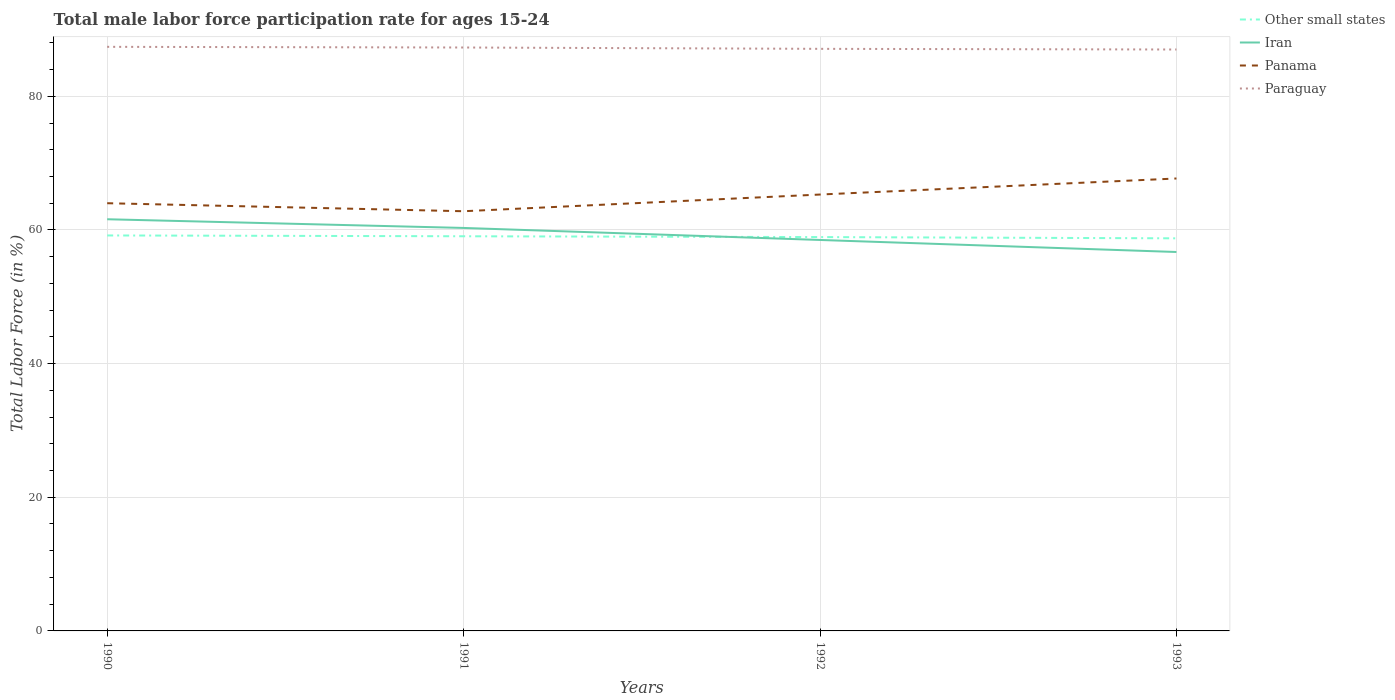Across all years, what is the maximum male labor force participation rate in Other small states?
Your answer should be very brief. 58.75. What is the total male labor force participation rate in Panama in the graph?
Your answer should be compact. -1.3. What is the difference between the highest and the second highest male labor force participation rate in Iran?
Provide a succinct answer. 4.9. What is the difference between the highest and the lowest male labor force participation rate in Other small states?
Provide a short and direct response. 2. Is the male labor force participation rate in Paraguay strictly greater than the male labor force participation rate in Other small states over the years?
Provide a succinct answer. No. Does the graph contain any zero values?
Offer a terse response. No. Does the graph contain grids?
Make the answer very short. Yes. Where does the legend appear in the graph?
Offer a very short reply. Top right. What is the title of the graph?
Ensure brevity in your answer.  Total male labor force participation rate for ages 15-24. Does "American Samoa" appear as one of the legend labels in the graph?
Your answer should be very brief. No. What is the label or title of the X-axis?
Your response must be concise. Years. What is the label or title of the Y-axis?
Give a very brief answer. Total Labor Force (in %). What is the Total Labor Force (in %) in Other small states in 1990?
Offer a very short reply. 59.18. What is the Total Labor Force (in %) in Iran in 1990?
Make the answer very short. 61.6. What is the Total Labor Force (in %) of Panama in 1990?
Your response must be concise. 64. What is the Total Labor Force (in %) of Paraguay in 1990?
Make the answer very short. 87.4. What is the Total Labor Force (in %) of Other small states in 1991?
Provide a succinct answer. 59.05. What is the Total Labor Force (in %) of Iran in 1991?
Your answer should be compact. 60.3. What is the Total Labor Force (in %) in Panama in 1991?
Your response must be concise. 62.8. What is the Total Labor Force (in %) in Paraguay in 1991?
Offer a terse response. 87.3. What is the Total Labor Force (in %) in Other small states in 1992?
Provide a succinct answer. 58.93. What is the Total Labor Force (in %) in Iran in 1992?
Your answer should be very brief. 58.5. What is the Total Labor Force (in %) in Panama in 1992?
Your response must be concise. 65.3. What is the Total Labor Force (in %) of Paraguay in 1992?
Offer a very short reply. 87.1. What is the Total Labor Force (in %) of Other small states in 1993?
Provide a short and direct response. 58.75. What is the Total Labor Force (in %) in Iran in 1993?
Your answer should be very brief. 56.7. What is the Total Labor Force (in %) of Panama in 1993?
Your answer should be compact. 67.7. Across all years, what is the maximum Total Labor Force (in %) of Other small states?
Keep it short and to the point. 59.18. Across all years, what is the maximum Total Labor Force (in %) of Iran?
Keep it short and to the point. 61.6. Across all years, what is the maximum Total Labor Force (in %) in Panama?
Provide a short and direct response. 67.7. Across all years, what is the maximum Total Labor Force (in %) of Paraguay?
Offer a terse response. 87.4. Across all years, what is the minimum Total Labor Force (in %) of Other small states?
Your answer should be very brief. 58.75. Across all years, what is the minimum Total Labor Force (in %) in Iran?
Ensure brevity in your answer.  56.7. Across all years, what is the minimum Total Labor Force (in %) in Panama?
Your answer should be very brief. 62.8. What is the total Total Labor Force (in %) in Other small states in the graph?
Offer a terse response. 235.91. What is the total Total Labor Force (in %) in Iran in the graph?
Offer a terse response. 237.1. What is the total Total Labor Force (in %) of Panama in the graph?
Provide a succinct answer. 259.8. What is the total Total Labor Force (in %) of Paraguay in the graph?
Offer a very short reply. 348.8. What is the difference between the Total Labor Force (in %) in Other small states in 1990 and that in 1991?
Your answer should be compact. 0.12. What is the difference between the Total Labor Force (in %) of Iran in 1990 and that in 1991?
Your answer should be very brief. 1.3. What is the difference between the Total Labor Force (in %) of Paraguay in 1990 and that in 1991?
Offer a terse response. 0.1. What is the difference between the Total Labor Force (in %) in Other small states in 1990 and that in 1992?
Provide a short and direct response. 0.24. What is the difference between the Total Labor Force (in %) in Paraguay in 1990 and that in 1992?
Your answer should be very brief. 0.3. What is the difference between the Total Labor Force (in %) of Other small states in 1990 and that in 1993?
Make the answer very short. 0.43. What is the difference between the Total Labor Force (in %) of Other small states in 1991 and that in 1992?
Provide a short and direct response. 0.12. What is the difference between the Total Labor Force (in %) in Other small states in 1991 and that in 1993?
Your answer should be compact. 0.31. What is the difference between the Total Labor Force (in %) in Iran in 1991 and that in 1993?
Your answer should be very brief. 3.6. What is the difference between the Total Labor Force (in %) of Paraguay in 1991 and that in 1993?
Offer a very short reply. 0.3. What is the difference between the Total Labor Force (in %) of Other small states in 1992 and that in 1993?
Make the answer very short. 0.19. What is the difference between the Total Labor Force (in %) of Panama in 1992 and that in 1993?
Your answer should be very brief. -2.4. What is the difference between the Total Labor Force (in %) in Other small states in 1990 and the Total Labor Force (in %) in Iran in 1991?
Offer a terse response. -1.12. What is the difference between the Total Labor Force (in %) in Other small states in 1990 and the Total Labor Force (in %) in Panama in 1991?
Give a very brief answer. -3.62. What is the difference between the Total Labor Force (in %) of Other small states in 1990 and the Total Labor Force (in %) of Paraguay in 1991?
Your answer should be compact. -28.12. What is the difference between the Total Labor Force (in %) in Iran in 1990 and the Total Labor Force (in %) in Paraguay in 1991?
Your response must be concise. -25.7. What is the difference between the Total Labor Force (in %) of Panama in 1990 and the Total Labor Force (in %) of Paraguay in 1991?
Provide a succinct answer. -23.3. What is the difference between the Total Labor Force (in %) of Other small states in 1990 and the Total Labor Force (in %) of Iran in 1992?
Provide a short and direct response. 0.68. What is the difference between the Total Labor Force (in %) in Other small states in 1990 and the Total Labor Force (in %) in Panama in 1992?
Ensure brevity in your answer.  -6.12. What is the difference between the Total Labor Force (in %) in Other small states in 1990 and the Total Labor Force (in %) in Paraguay in 1992?
Ensure brevity in your answer.  -27.92. What is the difference between the Total Labor Force (in %) in Iran in 1990 and the Total Labor Force (in %) in Paraguay in 1992?
Provide a short and direct response. -25.5. What is the difference between the Total Labor Force (in %) of Panama in 1990 and the Total Labor Force (in %) of Paraguay in 1992?
Provide a succinct answer. -23.1. What is the difference between the Total Labor Force (in %) in Other small states in 1990 and the Total Labor Force (in %) in Iran in 1993?
Keep it short and to the point. 2.48. What is the difference between the Total Labor Force (in %) of Other small states in 1990 and the Total Labor Force (in %) of Panama in 1993?
Your response must be concise. -8.52. What is the difference between the Total Labor Force (in %) in Other small states in 1990 and the Total Labor Force (in %) in Paraguay in 1993?
Offer a very short reply. -27.82. What is the difference between the Total Labor Force (in %) of Iran in 1990 and the Total Labor Force (in %) of Panama in 1993?
Make the answer very short. -6.1. What is the difference between the Total Labor Force (in %) in Iran in 1990 and the Total Labor Force (in %) in Paraguay in 1993?
Provide a short and direct response. -25.4. What is the difference between the Total Labor Force (in %) of Panama in 1990 and the Total Labor Force (in %) of Paraguay in 1993?
Offer a very short reply. -23. What is the difference between the Total Labor Force (in %) of Other small states in 1991 and the Total Labor Force (in %) of Iran in 1992?
Your answer should be very brief. 0.55. What is the difference between the Total Labor Force (in %) of Other small states in 1991 and the Total Labor Force (in %) of Panama in 1992?
Provide a short and direct response. -6.25. What is the difference between the Total Labor Force (in %) of Other small states in 1991 and the Total Labor Force (in %) of Paraguay in 1992?
Keep it short and to the point. -28.05. What is the difference between the Total Labor Force (in %) in Iran in 1991 and the Total Labor Force (in %) in Paraguay in 1992?
Ensure brevity in your answer.  -26.8. What is the difference between the Total Labor Force (in %) in Panama in 1991 and the Total Labor Force (in %) in Paraguay in 1992?
Ensure brevity in your answer.  -24.3. What is the difference between the Total Labor Force (in %) in Other small states in 1991 and the Total Labor Force (in %) in Iran in 1993?
Offer a very short reply. 2.35. What is the difference between the Total Labor Force (in %) of Other small states in 1991 and the Total Labor Force (in %) of Panama in 1993?
Your response must be concise. -8.65. What is the difference between the Total Labor Force (in %) of Other small states in 1991 and the Total Labor Force (in %) of Paraguay in 1993?
Your answer should be very brief. -27.95. What is the difference between the Total Labor Force (in %) of Iran in 1991 and the Total Labor Force (in %) of Paraguay in 1993?
Provide a succinct answer. -26.7. What is the difference between the Total Labor Force (in %) of Panama in 1991 and the Total Labor Force (in %) of Paraguay in 1993?
Provide a succinct answer. -24.2. What is the difference between the Total Labor Force (in %) in Other small states in 1992 and the Total Labor Force (in %) in Iran in 1993?
Provide a succinct answer. 2.23. What is the difference between the Total Labor Force (in %) in Other small states in 1992 and the Total Labor Force (in %) in Panama in 1993?
Your answer should be compact. -8.77. What is the difference between the Total Labor Force (in %) in Other small states in 1992 and the Total Labor Force (in %) in Paraguay in 1993?
Your answer should be compact. -28.07. What is the difference between the Total Labor Force (in %) in Iran in 1992 and the Total Labor Force (in %) in Paraguay in 1993?
Your response must be concise. -28.5. What is the difference between the Total Labor Force (in %) of Panama in 1992 and the Total Labor Force (in %) of Paraguay in 1993?
Give a very brief answer. -21.7. What is the average Total Labor Force (in %) of Other small states per year?
Your answer should be compact. 58.98. What is the average Total Labor Force (in %) of Iran per year?
Give a very brief answer. 59.27. What is the average Total Labor Force (in %) of Panama per year?
Provide a succinct answer. 64.95. What is the average Total Labor Force (in %) of Paraguay per year?
Provide a short and direct response. 87.2. In the year 1990, what is the difference between the Total Labor Force (in %) in Other small states and Total Labor Force (in %) in Iran?
Your answer should be compact. -2.42. In the year 1990, what is the difference between the Total Labor Force (in %) in Other small states and Total Labor Force (in %) in Panama?
Offer a terse response. -4.82. In the year 1990, what is the difference between the Total Labor Force (in %) of Other small states and Total Labor Force (in %) of Paraguay?
Offer a terse response. -28.22. In the year 1990, what is the difference between the Total Labor Force (in %) in Iran and Total Labor Force (in %) in Paraguay?
Offer a terse response. -25.8. In the year 1990, what is the difference between the Total Labor Force (in %) of Panama and Total Labor Force (in %) of Paraguay?
Provide a succinct answer. -23.4. In the year 1991, what is the difference between the Total Labor Force (in %) in Other small states and Total Labor Force (in %) in Iran?
Offer a terse response. -1.25. In the year 1991, what is the difference between the Total Labor Force (in %) of Other small states and Total Labor Force (in %) of Panama?
Your answer should be compact. -3.75. In the year 1991, what is the difference between the Total Labor Force (in %) of Other small states and Total Labor Force (in %) of Paraguay?
Offer a very short reply. -28.25. In the year 1991, what is the difference between the Total Labor Force (in %) of Panama and Total Labor Force (in %) of Paraguay?
Your answer should be compact. -24.5. In the year 1992, what is the difference between the Total Labor Force (in %) in Other small states and Total Labor Force (in %) in Iran?
Keep it short and to the point. 0.43. In the year 1992, what is the difference between the Total Labor Force (in %) of Other small states and Total Labor Force (in %) of Panama?
Offer a very short reply. -6.37. In the year 1992, what is the difference between the Total Labor Force (in %) of Other small states and Total Labor Force (in %) of Paraguay?
Offer a terse response. -28.17. In the year 1992, what is the difference between the Total Labor Force (in %) of Iran and Total Labor Force (in %) of Paraguay?
Your response must be concise. -28.6. In the year 1992, what is the difference between the Total Labor Force (in %) of Panama and Total Labor Force (in %) of Paraguay?
Make the answer very short. -21.8. In the year 1993, what is the difference between the Total Labor Force (in %) of Other small states and Total Labor Force (in %) of Iran?
Provide a short and direct response. 2.05. In the year 1993, what is the difference between the Total Labor Force (in %) of Other small states and Total Labor Force (in %) of Panama?
Ensure brevity in your answer.  -8.95. In the year 1993, what is the difference between the Total Labor Force (in %) in Other small states and Total Labor Force (in %) in Paraguay?
Provide a succinct answer. -28.25. In the year 1993, what is the difference between the Total Labor Force (in %) of Iran and Total Labor Force (in %) of Paraguay?
Ensure brevity in your answer.  -30.3. In the year 1993, what is the difference between the Total Labor Force (in %) in Panama and Total Labor Force (in %) in Paraguay?
Ensure brevity in your answer.  -19.3. What is the ratio of the Total Labor Force (in %) in Other small states in 1990 to that in 1991?
Your response must be concise. 1. What is the ratio of the Total Labor Force (in %) in Iran in 1990 to that in 1991?
Your answer should be very brief. 1.02. What is the ratio of the Total Labor Force (in %) in Panama in 1990 to that in 1991?
Your answer should be very brief. 1.02. What is the ratio of the Total Labor Force (in %) in Other small states in 1990 to that in 1992?
Make the answer very short. 1. What is the ratio of the Total Labor Force (in %) in Iran in 1990 to that in 1992?
Ensure brevity in your answer.  1.05. What is the ratio of the Total Labor Force (in %) of Panama in 1990 to that in 1992?
Keep it short and to the point. 0.98. What is the ratio of the Total Labor Force (in %) in Paraguay in 1990 to that in 1992?
Give a very brief answer. 1. What is the ratio of the Total Labor Force (in %) in Other small states in 1990 to that in 1993?
Your answer should be compact. 1.01. What is the ratio of the Total Labor Force (in %) of Iran in 1990 to that in 1993?
Your answer should be very brief. 1.09. What is the ratio of the Total Labor Force (in %) of Panama in 1990 to that in 1993?
Make the answer very short. 0.95. What is the ratio of the Total Labor Force (in %) in Paraguay in 1990 to that in 1993?
Your answer should be very brief. 1. What is the ratio of the Total Labor Force (in %) of Other small states in 1991 to that in 1992?
Keep it short and to the point. 1. What is the ratio of the Total Labor Force (in %) in Iran in 1991 to that in 1992?
Your answer should be compact. 1.03. What is the ratio of the Total Labor Force (in %) of Panama in 1991 to that in 1992?
Your response must be concise. 0.96. What is the ratio of the Total Labor Force (in %) in Other small states in 1991 to that in 1993?
Offer a terse response. 1.01. What is the ratio of the Total Labor Force (in %) of Iran in 1991 to that in 1993?
Your answer should be very brief. 1.06. What is the ratio of the Total Labor Force (in %) of Panama in 1991 to that in 1993?
Your answer should be compact. 0.93. What is the ratio of the Total Labor Force (in %) of Other small states in 1992 to that in 1993?
Give a very brief answer. 1. What is the ratio of the Total Labor Force (in %) in Iran in 1992 to that in 1993?
Provide a succinct answer. 1.03. What is the ratio of the Total Labor Force (in %) of Panama in 1992 to that in 1993?
Ensure brevity in your answer.  0.96. What is the difference between the highest and the second highest Total Labor Force (in %) of Other small states?
Offer a very short reply. 0.12. What is the difference between the highest and the second highest Total Labor Force (in %) in Iran?
Your answer should be very brief. 1.3. What is the difference between the highest and the lowest Total Labor Force (in %) of Other small states?
Ensure brevity in your answer.  0.43. What is the difference between the highest and the lowest Total Labor Force (in %) in Iran?
Provide a short and direct response. 4.9. What is the difference between the highest and the lowest Total Labor Force (in %) of Panama?
Provide a short and direct response. 4.9. What is the difference between the highest and the lowest Total Labor Force (in %) of Paraguay?
Provide a short and direct response. 0.4. 